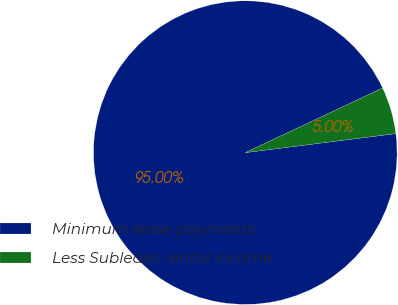Convert chart to OTSL. <chart><loc_0><loc_0><loc_500><loc_500><pie_chart><fcel>Minimum lease payments<fcel>Less Sublease rental income<nl><fcel>95.0%<fcel>5.0%<nl></chart> 